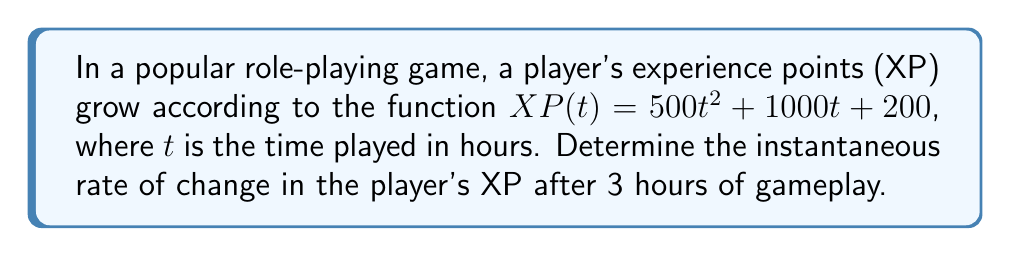Can you answer this question? To find the instantaneous rate of change in the player's XP after 3 hours, we need to calculate the derivative of the XP function and evaluate it at $t = 3$.

1. First, let's find the derivative of $XP(t)$:
   
   $XP(t) = 500t^2 + 1000t + 200$
   
   Using the power rule and constant rule of differentiation:
   
   $\frac{d}{dt}XP(t) = \frac{d}{dt}(500t^2) + \frac{d}{dt}(1000t) + \frac{d}{dt}(200)$
   
   $\frac{d}{dt}XP(t) = 1000t + 1000 + 0$
   
   $\frac{d}{dt}XP(t) = 1000t + 1000$

2. Now that we have the derivative, which represents the instantaneous rate of change, we can evaluate it at $t = 3$:

   $\left.\frac{d}{dt}XP(t)\right|_{t=3} = 1000(3) + 1000$
   
   $\left.\frac{d}{dt}XP(t)\right|_{t=3} = 3000 + 1000 = 4000$

Therefore, the instantaneous rate of change in the player's XP after 3 hours of gameplay is 4000 XP per hour.
Answer: 4000 XP per hour 